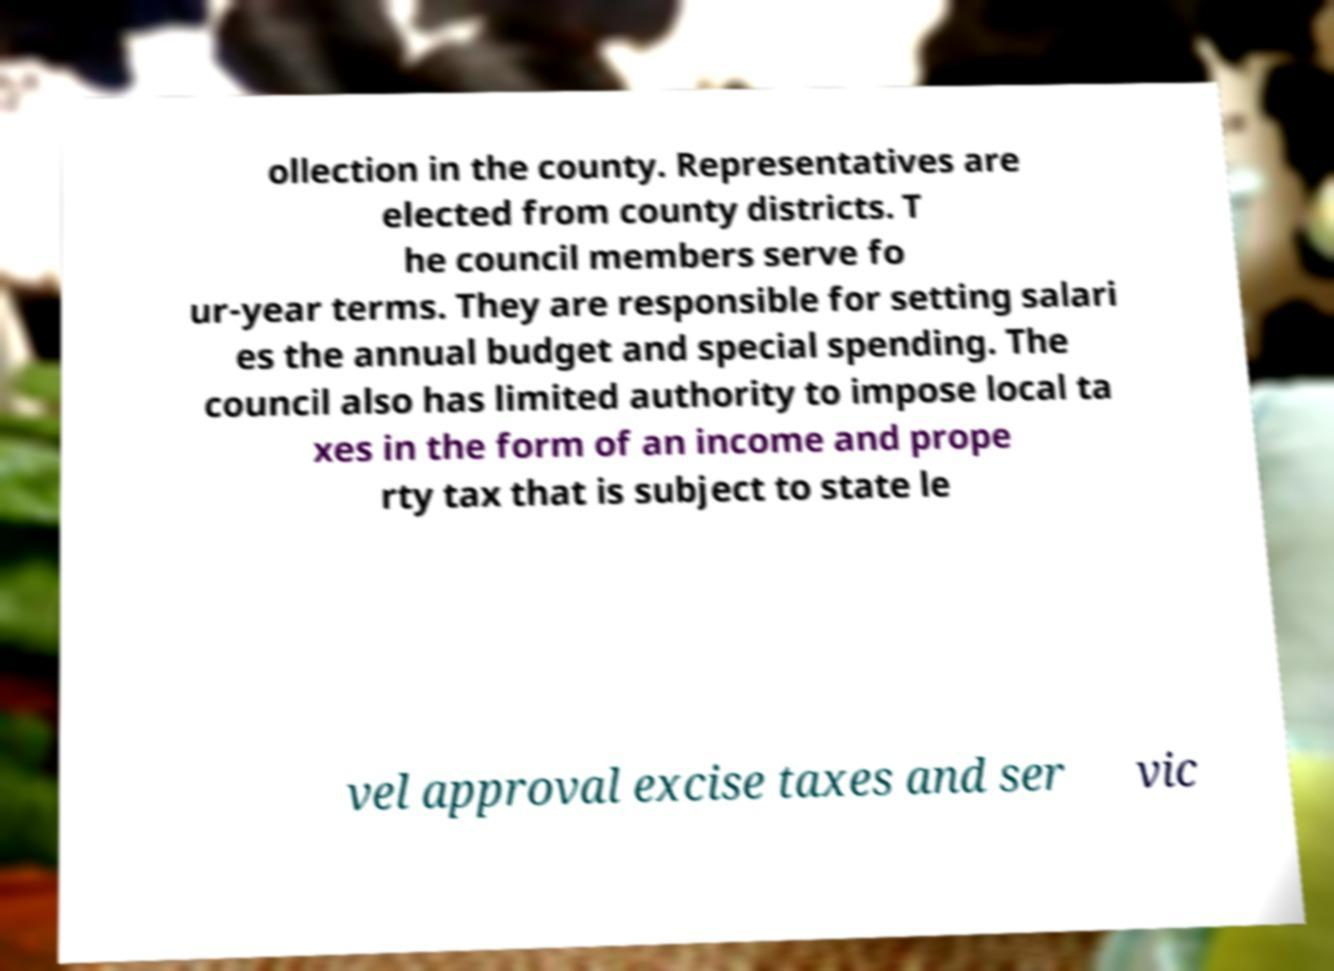Please read and relay the text visible in this image. What does it say? ollection in the county. Representatives are elected from county districts. T he council members serve fo ur-year terms. They are responsible for setting salari es the annual budget and special spending. The council also has limited authority to impose local ta xes in the form of an income and prope rty tax that is subject to state le vel approval excise taxes and ser vic 